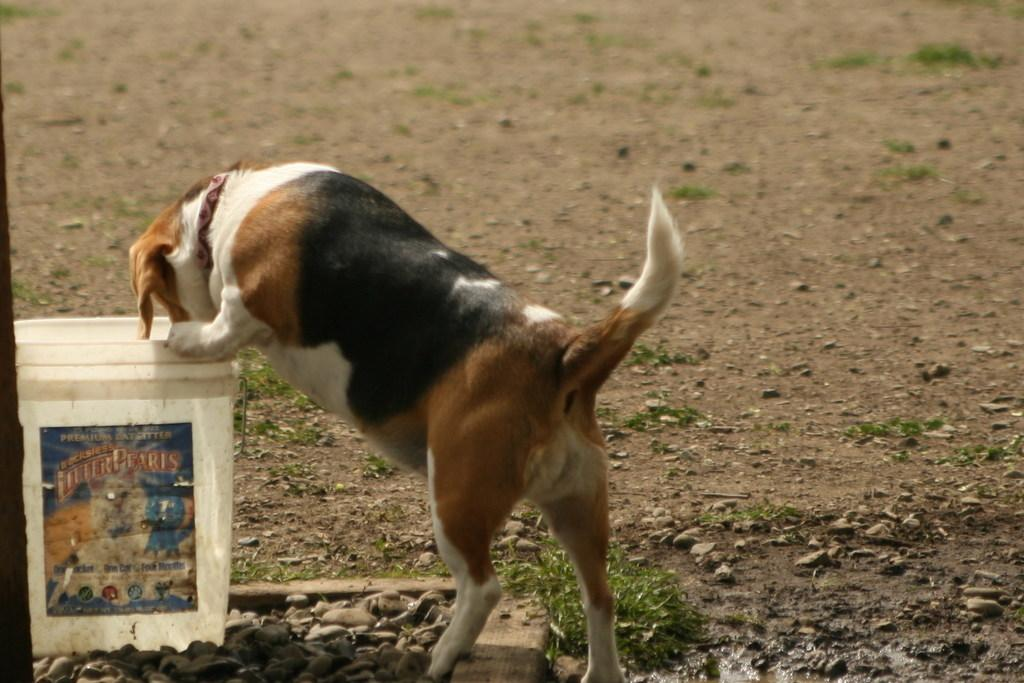What animal is present in the image? There is a dog in the image. What is the dog doing in the image? The dog is at a bucket. What type of surface is visible in the background of the image? There is ground visible in the background of the image. What is the dog's existence judged by in the image? The dog's existence is not being judged by anything in the image; it is simply present. What sense is the dog using to interact with the bucket in the image? The dog's sense of interaction with the bucket is not specified in the image. 